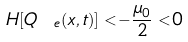<formula> <loc_0><loc_0><loc_500><loc_500>H [ Q _ { \ e } ( x , t ) ] < - \frac { \mu _ { 0 } } { 2 } < 0</formula> 